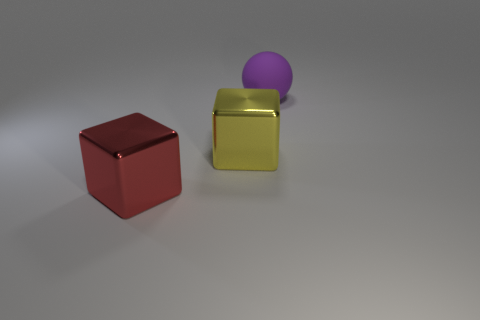Add 2 big metal cubes. How many objects exist? 5 Subtract all cubes. How many objects are left? 1 Subtract all yellow cubes. How many cubes are left? 1 Subtract 1 blocks. How many blocks are left? 1 Subtract all large things. Subtract all green metal cylinders. How many objects are left? 0 Add 1 big cubes. How many big cubes are left? 3 Add 3 big red objects. How many big red objects exist? 4 Subtract 0 gray cubes. How many objects are left? 3 Subtract all blue blocks. Subtract all red balls. How many blocks are left? 2 